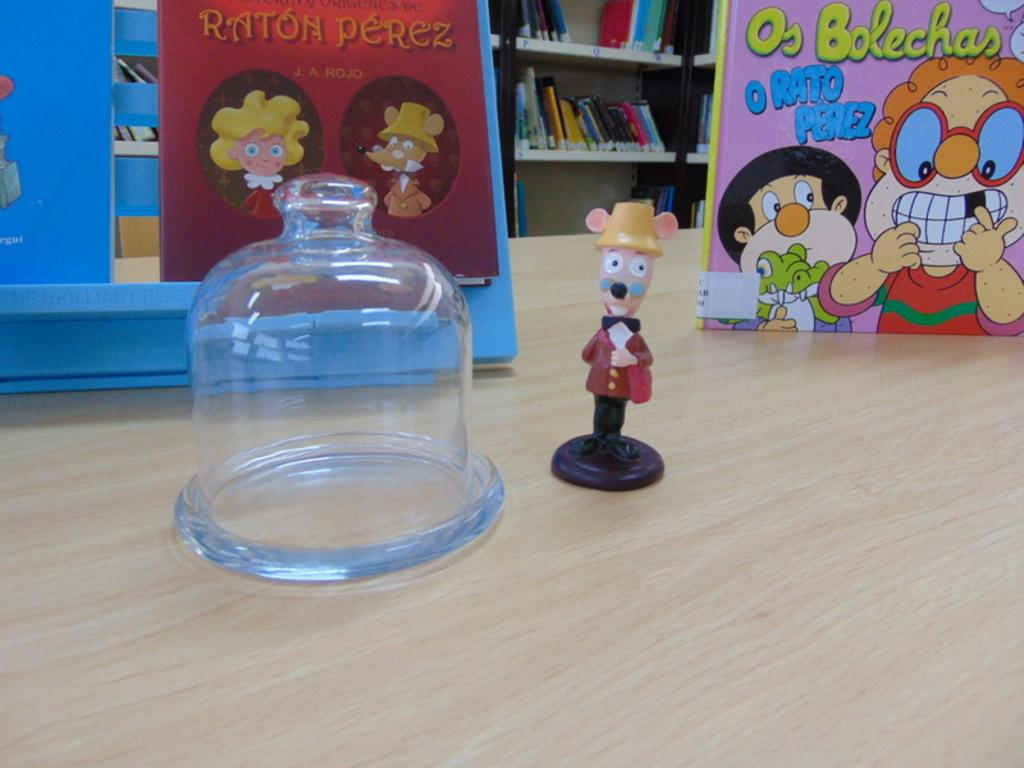Provide a one-sentence caption for the provided image. A Raton Perez toy is on the table in front of some Raton Perez books. 